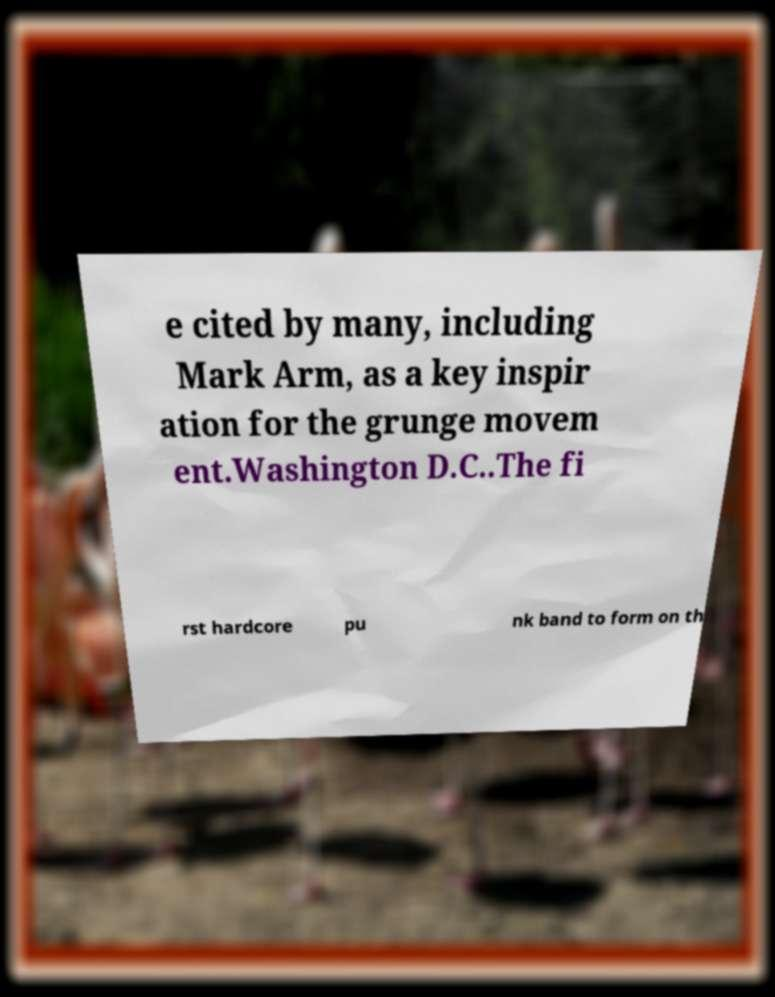For documentation purposes, I need the text within this image transcribed. Could you provide that? e cited by many, including Mark Arm, as a key inspir ation for the grunge movem ent.Washington D.C..The fi rst hardcore pu nk band to form on th 